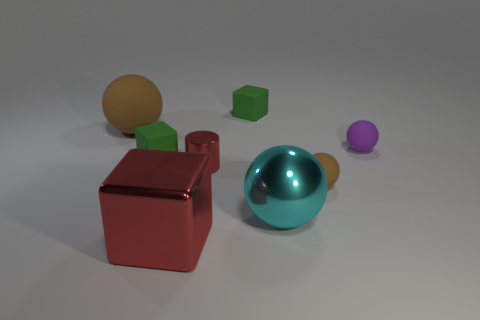There is a rubber sphere behind the purple rubber object that is behind the red metal cylinder; how many small brown matte balls are in front of it?
Your answer should be very brief. 1. There is a brown object that is the same size as the metallic cube; what is it made of?
Make the answer very short. Rubber. Are there any yellow rubber things that have the same size as the metallic sphere?
Offer a very short reply. No. What is the color of the cylinder?
Keep it short and to the point. Red. The big sphere that is right of the rubber block that is on the right side of the metallic cylinder is what color?
Make the answer very short. Cyan. What is the shape of the large object that is right of the rubber block behind the big ball behind the big cyan shiny object?
Your answer should be very brief. Sphere. How many other small purple objects have the same material as the tiny purple object?
Your response must be concise. 0. What number of tiny brown balls are in front of the brown thing that is on the right side of the tiny red thing?
Offer a terse response. 0. How many brown balls are there?
Provide a succinct answer. 2. Are the small brown sphere and the tiny cube that is in front of the tiny purple thing made of the same material?
Make the answer very short. Yes. 